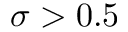<formula> <loc_0><loc_0><loc_500><loc_500>\sigma > 0 . 5</formula> 